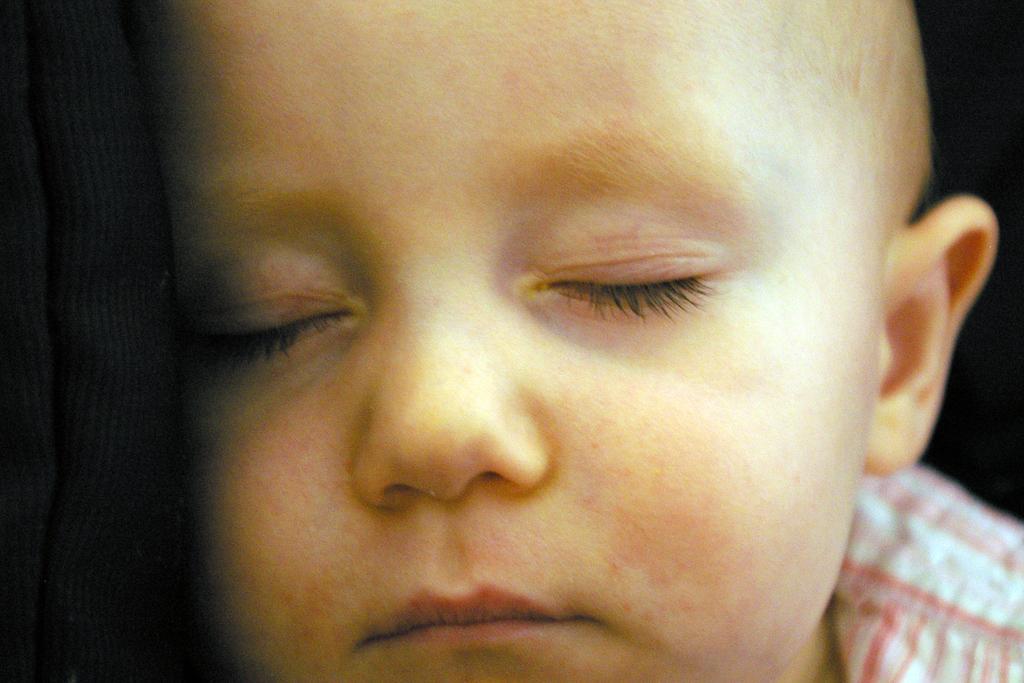Can you describe this image briefly? In this image, there is a small kid sleeping, at the left side there is a black color object. 